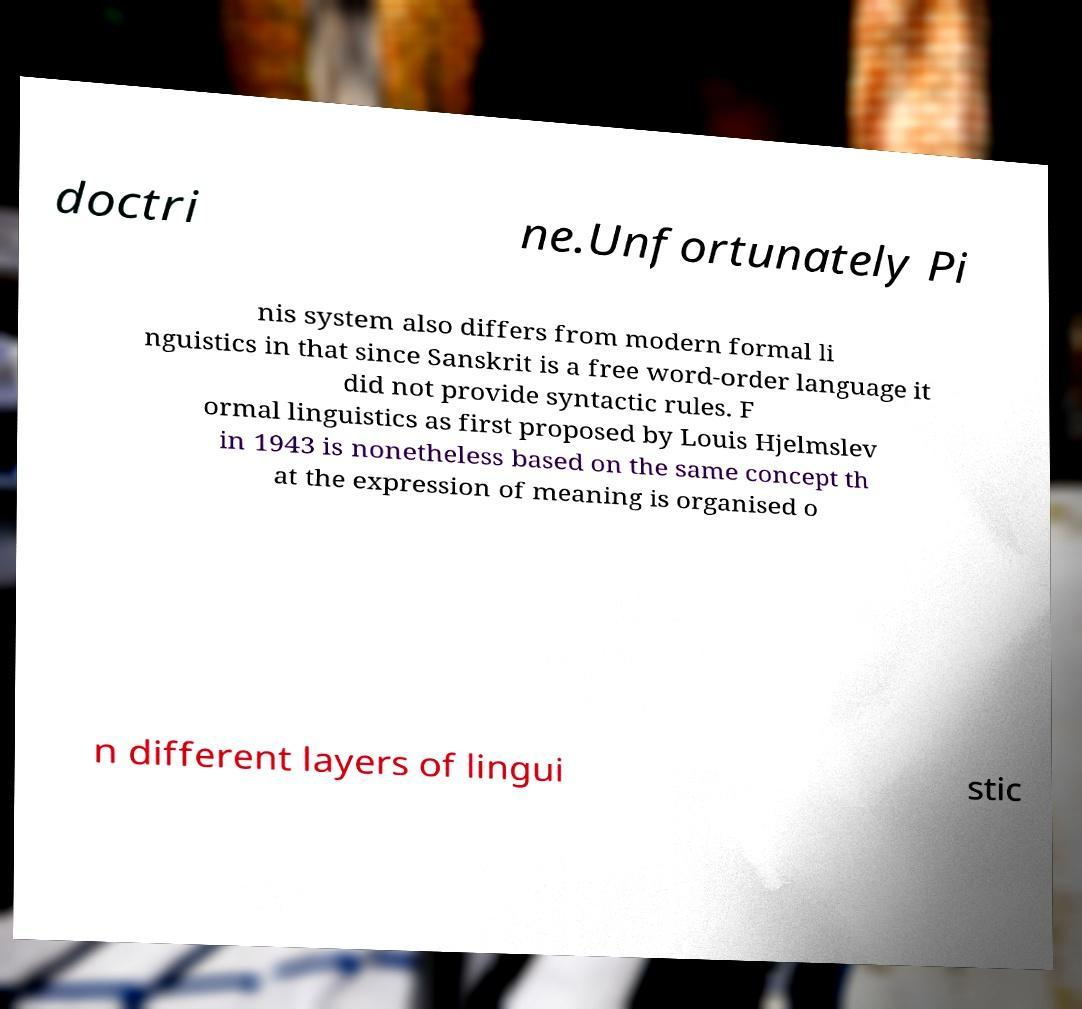Can you read and provide the text displayed in the image?This photo seems to have some interesting text. Can you extract and type it out for me? doctri ne.Unfortunately Pi nis system also differs from modern formal li nguistics in that since Sanskrit is a free word-order language it did not provide syntactic rules. F ormal linguistics as first proposed by Louis Hjelmslev in 1943 is nonetheless based on the same concept th at the expression of meaning is organised o n different layers of lingui stic 